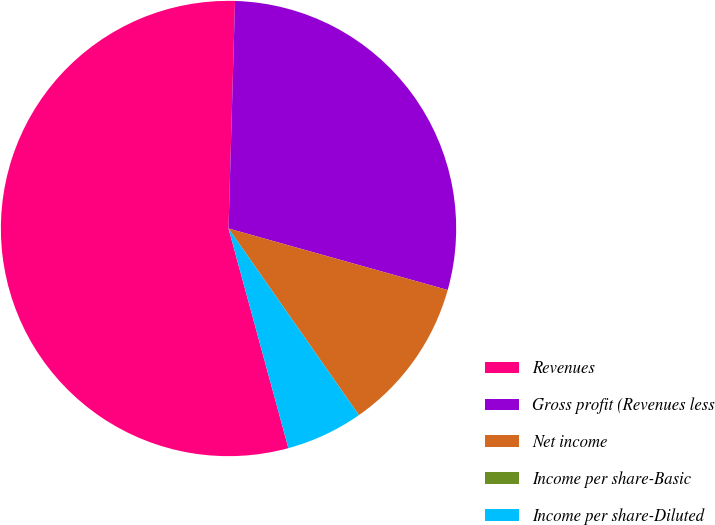Convert chart to OTSL. <chart><loc_0><loc_0><loc_500><loc_500><pie_chart><fcel>Revenues<fcel>Gross profit (Revenues less<fcel>Net income<fcel>Income per share-Basic<fcel>Income per share-Diluted<nl><fcel>54.69%<fcel>28.9%<fcel>10.94%<fcel>0.0%<fcel>5.47%<nl></chart> 